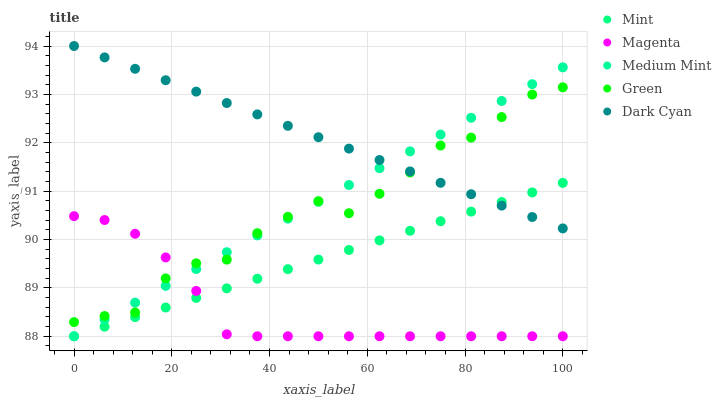Does Magenta have the minimum area under the curve?
Answer yes or no. Yes. Does Dark Cyan have the maximum area under the curve?
Answer yes or no. Yes. Does Green have the minimum area under the curve?
Answer yes or no. No. Does Green have the maximum area under the curve?
Answer yes or no. No. Is Mint the smoothest?
Answer yes or no. Yes. Is Green the roughest?
Answer yes or no. Yes. Is Magenta the smoothest?
Answer yes or no. No. Is Magenta the roughest?
Answer yes or no. No. Does Medium Mint have the lowest value?
Answer yes or no. Yes. Does Green have the lowest value?
Answer yes or no. No. Does Dark Cyan have the highest value?
Answer yes or no. Yes. Does Green have the highest value?
Answer yes or no. No. Is Magenta less than Dark Cyan?
Answer yes or no. Yes. Is Dark Cyan greater than Magenta?
Answer yes or no. Yes. Does Mint intersect Magenta?
Answer yes or no. Yes. Is Mint less than Magenta?
Answer yes or no. No. Is Mint greater than Magenta?
Answer yes or no. No. Does Magenta intersect Dark Cyan?
Answer yes or no. No. 